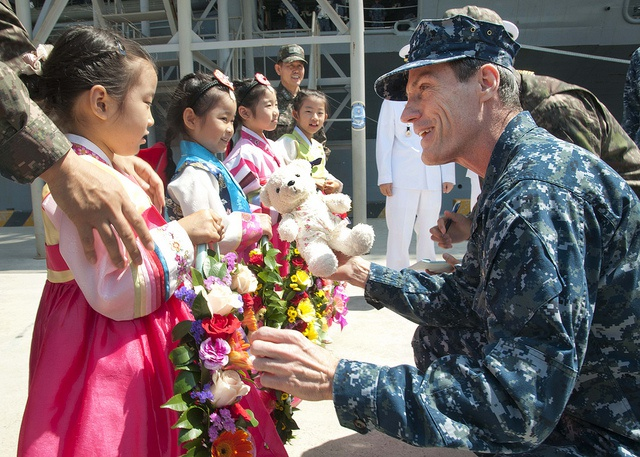Describe the objects in this image and their specific colors. I can see people in gray, black, and blue tones, people in gray, brown, and maroon tones, people in gray, black, and ivory tones, people in gray, white, and black tones, and people in gray, lavender, and darkgray tones in this image. 